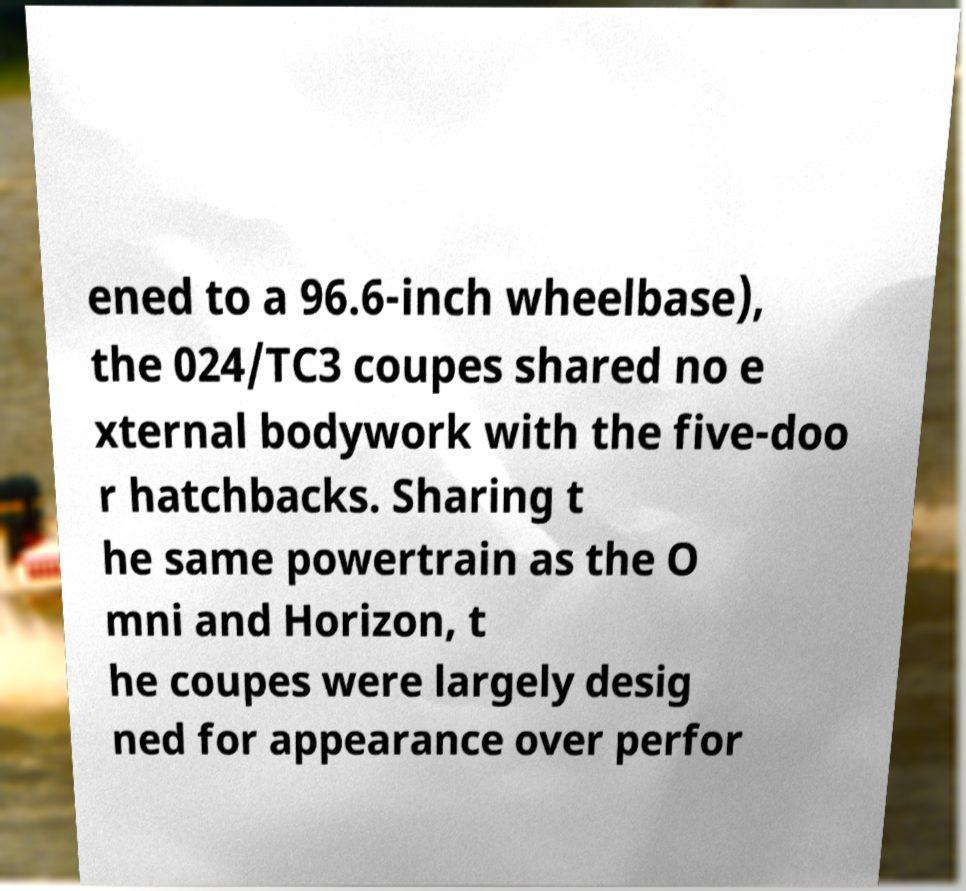What messages or text are displayed in this image? I need them in a readable, typed format. ened to a 96.6-inch wheelbase), the 024/TC3 coupes shared no e xternal bodywork with the five-doo r hatchbacks. Sharing t he same powertrain as the O mni and Horizon, t he coupes were largely desig ned for appearance over perfor 